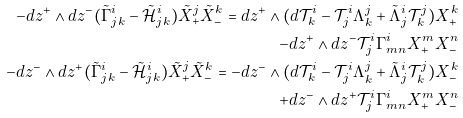Convert formula to latex. <formula><loc_0><loc_0><loc_500><loc_500>- d z ^ { + } \wedge d z ^ { - } ( \tilde { \Gamma } _ { j k } ^ { i } - \mathcal { \tilde { H } } _ { j k } ^ { i } ) \tilde { X } _ { + } ^ { j } \tilde { X } _ { - } ^ { k } = d z ^ { + } \wedge ( d \mathcal { T } _ { k } ^ { i } - \mathcal { T } _ { j } ^ { i } \Lambda _ { k } ^ { j } + \tilde { \Lambda } _ { j } ^ { i } \mathcal { T } _ { k } ^ { j } ) X _ { + } ^ { k } \\ - d z ^ { + } \wedge d z ^ { - } \mathcal { T } _ { j } ^ { i } \Gamma _ { m n } ^ { i } X _ { + } ^ { m } X _ { - } ^ { n } \\ - d z ^ { - } \wedge d z ^ { + } ( \tilde { \Gamma } _ { j k } ^ { i } - \mathcal { \tilde { H } } _ { j k } ^ { i } ) \tilde { X } _ { + } ^ { j } \tilde { X } _ { - } ^ { k } = - d z ^ { - } \wedge ( d \mathcal { T } _ { k } ^ { i } - \mathcal { T } _ { j } ^ { i } \Lambda _ { k } ^ { j } + \tilde { \Lambda } _ { j } ^ { i } \mathcal { T } _ { k } ^ { j } ) X _ { - } ^ { k } \\ + d z ^ { - } \wedge d z ^ { + } \mathcal { T } _ { j } ^ { i } \Gamma _ { m n } ^ { i } X _ { + } ^ { m } X _ { - } ^ { n }</formula> 